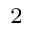<formula> <loc_0><loc_0><loc_500><loc_500>_ { 2 }</formula> 